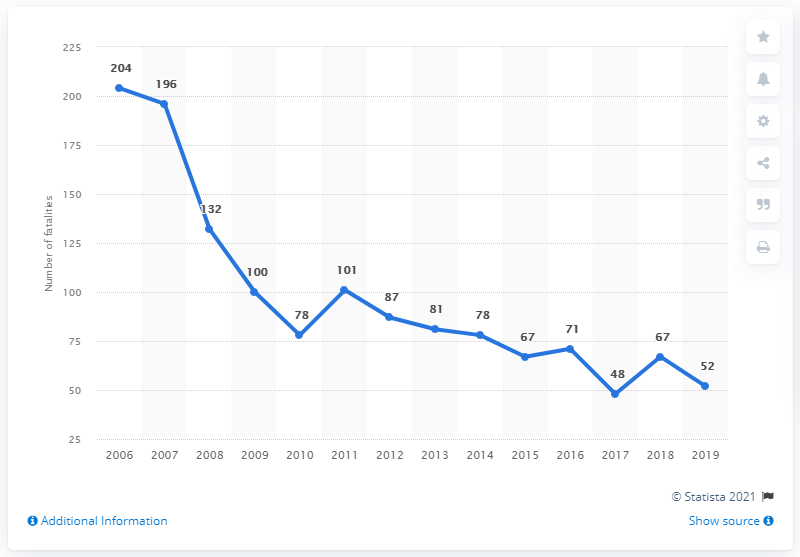Point out several critical features in this image. In 2009, 100 people were killed in motor vehicle accidents. In 2006, there were 204 road fatalities. The traffic is decreasing. In 2019, there were 52 road traffic fatalities in Estonia. The median of the last five values is 48. 